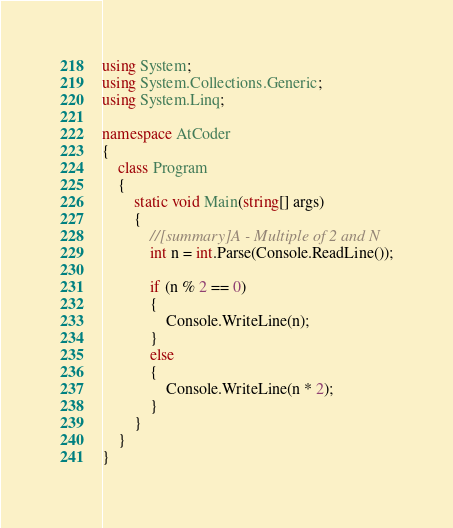Convert code to text. <code><loc_0><loc_0><loc_500><loc_500><_C#_>using System;
using System.Collections.Generic;
using System.Linq;

namespace AtCoder
{
    class Program
    {
        static void Main(string[] args)
        {
            //[summary]A - Multiple of 2 and N
            int n = int.Parse(Console.ReadLine());
            
            if (n % 2 == 0)
            {
                Console.WriteLine(n);
            }
            else
            {
                Console.WriteLine(n * 2);
            }            
        }
    }
}</code> 